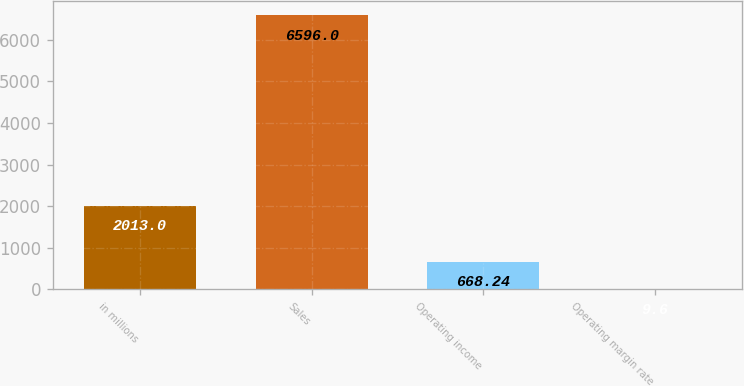<chart> <loc_0><loc_0><loc_500><loc_500><bar_chart><fcel>in millions<fcel>Sales<fcel>Operating income<fcel>Operating margin rate<nl><fcel>2013<fcel>6596<fcel>668.24<fcel>9.6<nl></chart> 